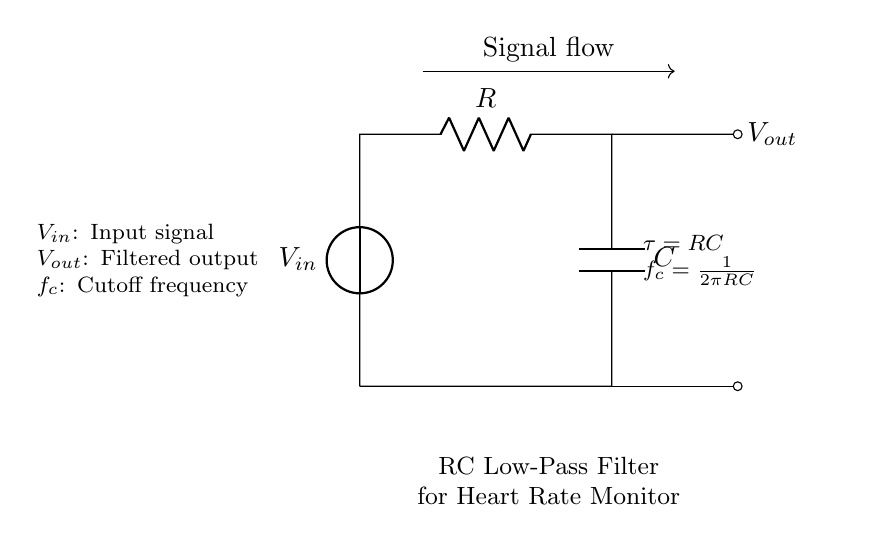What is the input signal labeled as in the circuit? The input signal is labeled as V_in, which indicates the source of the signal entering the circuit.
Answer: V_in What components are present in the circuit? The circuit comprises a voltage source, a resistor, and a capacitor, as shown by the labels in the diagram.
Answer: Voltage source, resistor, and capacitor What is the output voltage labeled as? The output voltage is labeled as V_out, which represents the filtered signal leaving the circuit.
Answer: V_out What does the symbol τ represent in this circuit? The symbol τ represents the time constant, calculated as the product of the resistor value R and the capacitor value C, indicating how quickly the circuit responds to changes.
Answer: τ What effect does increasing the capacitance have on the cutoff frequency? Increasing the capacitance reduces the cutoff frequency (f_c) since the formula shows an inverse relationship between capacitance and the cutoff frequency (f_c = 1/(2πRC)). This means the circuit will filter lower frequencies better.
Answer: Reduces cutoff frequency What is the cutoff frequency formula for this RC circuit? The cutoff frequency is given by the formula f_c = 1/(2πRC), which determines the frequency at which the output signal begins to attenuate significantly.
Answer: f_c = 1/(2πRC) How does the current flow in this RC circuit? The current flows from the voltage source (V_in) through the resistor (R) to the capacitor (C), and then back to the voltage source, creating a closed loop for current flow.
Answer: In a loop from V_in through R to C and back 